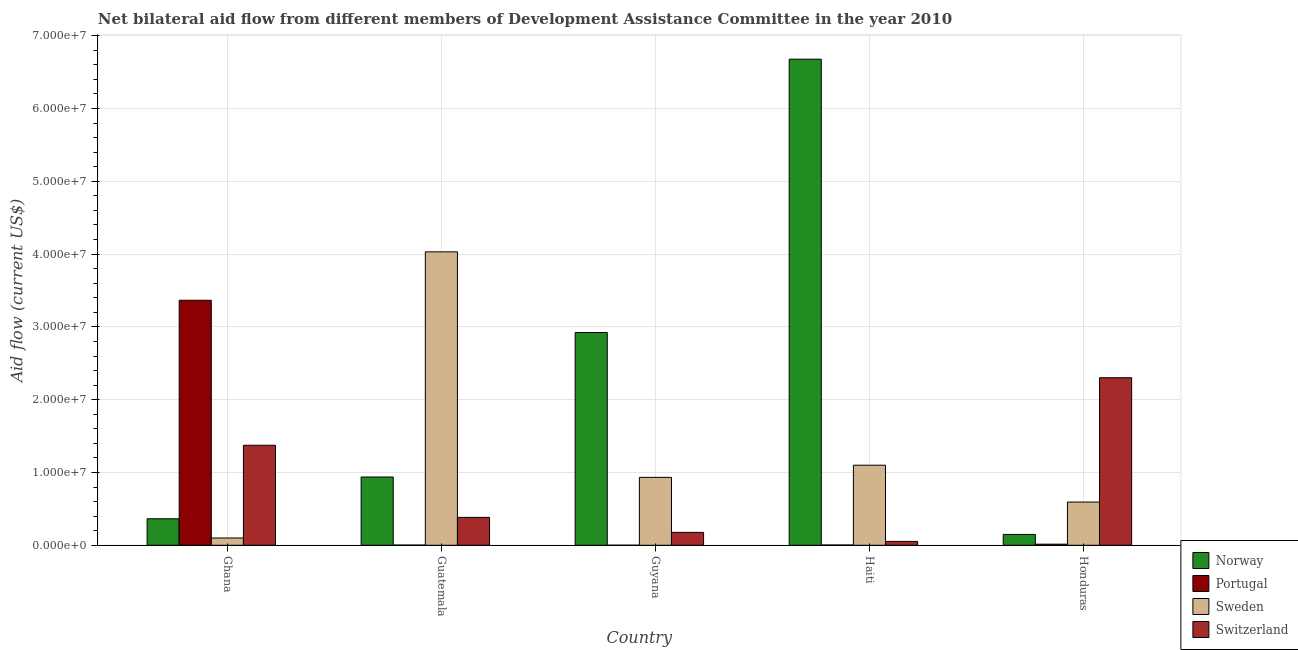What is the label of the 1st group of bars from the left?
Your response must be concise. Ghana. What is the amount of aid given by norway in Honduras?
Keep it short and to the point. 1.49e+06. Across all countries, what is the maximum amount of aid given by switzerland?
Your answer should be very brief. 2.30e+07. Across all countries, what is the minimum amount of aid given by norway?
Offer a terse response. 1.49e+06. In which country was the amount of aid given by sweden maximum?
Offer a very short reply. Guatemala. What is the total amount of aid given by sweden in the graph?
Your response must be concise. 6.76e+07. What is the difference between the amount of aid given by portugal in Ghana and that in Haiti?
Your answer should be very brief. 3.36e+07. What is the difference between the amount of aid given by portugal in Honduras and the amount of aid given by norway in Guatemala?
Your answer should be very brief. -9.23e+06. What is the average amount of aid given by sweden per country?
Provide a short and direct response. 1.35e+07. What is the difference between the amount of aid given by portugal and amount of aid given by sweden in Guatemala?
Offer a terse response. -4.03e+07. In how many countries, is the amount of aid given by sweden greater than 34000000 US$?
Your answer should be compact. 1. What is the ratio of the amount of aid given by switzerland in Guyana to that in Honduras?
Provide a short and direct response. 0.08. What is the difference between the highest and the second highest amount of aid given by norway?
Give a very brief answer. 3.76e+07. What is the difference between the highest and the lowest amount of aid given by sweden?
Your response must be concise. 3.93e+07. What does the 1st bar from the right in Haiti represents?
Your answer should be very brief. Switzerland. Is it the case that in every country, the sum of the amount of aid given by norway and amount of aid given by portugal is greater than the amount of aid given by sweden?
Your response must be concise. No. Are all the bars in the graph horizontal?
Offer a terse response. No. How many countries are there in the graph?
Ensure brevity in your answer.  5. Does the graph contain grids?
Offer a terse response. Yes. Where does the legend appear in the graph?
Provide a succinct answer. Bottom right. How many legend labels are there?
Provide a short and direct response. 4. How are the legend labels stacked?
Keep it short and to the point. Vertical. What is the title of the graph?
Provide a short and direct response. Net bilateral aid flow from different members of Development Assistance Committee in the year 2010. What is the label or title of the Y-axis?
Your answer should be very brief. Aid flow (current US$). What is the Aid flow (current US$) of Norway in Ghana?
Make the answer very short. 3.64e+06. What is the Aid flow (current US$) of Portugal in Ghana?
Give a very brief answer. 3.37e+07. What is the Aid flow (current US$) of Switzerland in Ghana?
Provide a succinct answer. 1.37e+07. What is the Aid flow (current US$) of Norway in Guatemala?
Your response must be concise. 9.38e+06. What is the Aid flow (current US$) in Sweden in Guatemala?
Keep it short and to the point. 4.03e+07. What is the Aid flow (current US$) of Switzerland in Guatemala?
Make the answer very short. 3.83e+06. What is the Aid flow (current US$) of Norway in Guyana?
Keep it short and to the point. 2.92e+07. What is the Aid flow (current US$) of Sweden in Guyana?
Offer a terse response. 9.33e+06. What is the Aid flow (current US$) of Switzerland in Guyana?
Offer a terse response. 1.77e+06. What is the Aid flow (current US$) of Norway in Haiti?
Your response must be concise. 6.68e+07. What is the Aid flow (current US$) in Sweden in Haiti?
Your answer should be compact. 1.10e+07. What is the Aid flow (current US$) in Switzerland in Haiti?
Keep it short and to the point. 5.30e+05. What is the Aid flow (current US$) of Norway in Honduras?
Your answer should be compact. 1.49e+06. What is the Aid flow (current US$) in Portugal in Honduras?
Your answer should be very brief. 1.50e+05. What is the Aid flow (current US$) in Sweden in Honduras?
Provide a short and direct response. 5.94e+06. What is the Aid flow (current US$) in Switzerland in Honduras?
Give a very brief answer. 2.30e+07. Across all countries, what is the maximum Aid flow (current US$) of Norway?
Your answer should be compact. 6.68e+07. Across all countries, what is the maximum Aid flow (current US$) of Portugal?
Provide a short and direct response. 3.37e+07. Across all countries, what is the maximum Aid flow (current US$) of Sweden?
Your response must be concise. 4.03e+07. Across all countries, what is the maximum Aid flow (current US$) of Switzerland?
Offer a very short reply. 2.30e+07. Across all countries, what is the minimum Aid flow (current US$) in Norway?
Give a very brief answer. 1.49e+06. Across all countries, what is the minimum Aid flow (current US$) in Portugal?
Provide a succinct answer. 10000. Across all countries, what is the minimum Aid flow (current US$) of Sweden?
Your answer should be compact. 1.00e+06. Across all countries, what is the minimum Aid flow (current US$) in Switzerland?
Offer a very short reply. 5.30e+05. What is the total Aid flow (current US$) of Norway in the graph?
Keep it short and to the point. 1.11e+08. What is the total Aid flow (current US$) of Portugal in the graph?
Your answer should be compact. 3.39e+07. What is the total Aid flow (current US$) in Sweden in the graph?
Keep it short and to the point. 6.76e+07. What is the total Aid flow (current US$) in Switzerland in the graph?
Offer a terse response. 4.29e+07. What is the difference between the Aid flow (current US$) in Norway in Ghana and that in Guatemala?
Give a very brief answer. -5.74e+06. What is the difference between the Aid flow (current US$) of Portugal in Ghana and that in Guatemala?
Give a very brief answer. 3.36e+07. What is the difference between the Aid flow (current US$) in Sweden in Ghana and that in Guatemala?
Provide a succinct answer. -3.93e+07. What is the difference between the Aid flow (current US$) in Switzerland in Ghana and that in Guatemala?
Offer a very short reply. 9.91e+06. What is the difference between the Aid flow (current US$) in Norway in Ghana and that in Guyana?
Provide a short and direct response. -2.56e+07. What is the difference between the Aid flow (current US$) of Portugal in Ghana and that in Guyana?
Offer a terse response. 3.36e+07. What is the difference between the Aid flow (current US$) of Sweden in Ghana and that in Guyana?
Give a very brief answer. -8.33e+06. What is the difference between the Aid flow (current US$) of Switzerland in Ghana and that in Guyana?
Provide a succinct answer. 1.20e+07. What is the difference between the Aid flow (current US$) in Norway in Ghana and that in Haiti?
Your answer should be compact. -6.31e+07. What is the difference between the Aid flow (current US$) of Portugal in Ghana and that in Haiti?
Keep it short and to the point. 3.36e+07. What is the difference between the Aid flow (current US$) of Sweden in Ghana and that in Haiti?
Make the answer very short. -1.00e+07. What is the difference between the Aid flow (current US$) of Switzerland in Ghana and that in Haiti?
Your answer should be compact. 1.32e+07. What is the difference between the Aid flow (current US$) of Norway in Ghana and that in Honduras?
Your answer should be compact. 2.15e+06. What is the difference between the Aid flow (current US$) of Portugal in Ghana and that in Honduras?
Give a very brief answer. 3.35e+07. What is the difference between the Aid flow (current US$) of Sweden in Ghana and that in Honduras?
Make the answer very short. -4.94e+06. What is the difference between the Aid flow (current US$) of Switzerland in Ghana and that in Honduras?
Offer a very short reply. -9.28e+06. What is the difference between the Aid flow (current US$) in Norway in Guatemala and that in Guyana?
Your response must be concise. -1.98e+07. What is the difference between the Aid flow (current US$) in Sweden in Guatemala and that in Guyana?
Your response must be concise. 3.10e+07. What is the difference between the Aid flow (current US$) in Switzerland in Guatemala and that in Guyana?
Make the answer very short. 2.06e+06. What is the difference between the Aid flow (current US$) of Norway in Guatemala and that in Haiti?
Provide a short and direct response. -5.74e+07. What is the difference between the Aid flow (current US$) in Sweden in Guatemala and that in Haiti?
Keep it short and to the point. 2.93e+07. What is the difference between the Aid flow (current US$) in Switzerland in Guatemala and that in Haiti?
Make the answer very short. 3.30e+06. What is the difference between the Aid flow (current US$) in Norway in Guatemala and that in Honduras?
Provide a succinct answer. 7.89e+06. What is the difference between the Aid flow (current US$) of Portugal in Guatemala and that in Honduras?
Your response must be concise. -1.20e+05. What is the difference between the Aid flow (current US$) in Sweden in Guatemala and that in Honduras?
Offer a very short reply. 3.44e+07. What is the difference between the Aid flow (current US$) of Switzerland in Guatemala and that in Honduras?
Your answer should be compact. -1.92e+07. What is the difference between the Aid flow (current US$) in Norway in Guyana and that in Haiti?
Make the answer very short. -3.76e+07. What is the difference between the Aid flow (current US$) in Portugal in Guyana and that in Haiti?
Offer a very short reply. -3.00e+04. What is the difference between the Aid flow (current US$) in Sweden in Guyana and that in Haiti?
Offer a terse response. -1.67e+06. What is the difference between the Aid flow (current US$) in Switzerland in Guyana and that in Haiti?
Your answer should be very brief. 1.24e+06. What is the difference between the Aid flow (current US$) of Norway in Guyana and that in Honduras?
Ensure brevity in your answer.  2.77e+07. What is the difference between the Aid flow (current US$) of Sweden in Guyana and that in Honduras?
Provide a short and direct response. 3.39e+06. What is the difference between the Aid flow (current US$) in Switzerland in Guyana and that in Honduras?
Your response must be concise. -2.12e+07. What is the difference between the Aid flow (current US$) of Norway in Haiti and that in Honduras?
Give a very brief answer. 6.53e+07. What is the difference between the Aid flow (current US$) of Sweden in Haiti and that in Honduras?
Make the answer very short. 5.06e+06. What is the difference between the Aid flow (current US$) in Switzerland in Haiti and that in Honduras?
Give a very brief answer. -2.25e+07. What is the difference between the Aid flow (current US$) of Norway in Ghana and the Aid flow (current US$) of Portugal in Guatemala?
Your answer should be compact. 3.61e+06. What is the difference between the Aid flow (current US$) in Norway in Ghana and the Aid flow (current US$) in Sweden in Guatemala?
Ensure brevity in your answer.  -3.67e+07. What is the difference between the Aid flow (current US$) of Norway in Ghana and the Aid flow (current US$) of Switzerland in Guatemala?
Provide a short and direct response. -1.90e+05. What is the difference between the Aid flow (current US$) of Portugal in Ghana and the Aid flow (current US$) of Sweden in Guatemala?
Ensure brevity in your answer.  -6.65e+06. What is the difference between the Aid flow (current US$) of Portugal in Ghana and the Aid flow (current US$) of Switzerland in Guatemala?
Give a very brief answer. 2.98e+07. What is the difference between the Aid flow (current US$) in Sweden in Ghana and the Aid flow (current US$) in Switzerland in Guatemala?
Offer a very short reply. -2.83e+06. What is the difference between the Aid flow (current US$) in Norway in Ghana and the Aid flow (current US$) in Portugal in Guyana?
Your response must be concise. 3.63e+06. What is the difference between the Aid flow (current US$) in Norway in Ghana and the Aid flow (current US$) in Sweden in Guyana?
Make the answer very short. -5.69e+06. What is the difference between the Aid flow (current US$) of Norway in Ghana and the Aid flow (current US$) of Switzerland in Guyana?
Offer a very short reply. 1.87e+06. What is the difference between the Aid flow (current US$) in Portugal in Ghana and the Aid flow (current US$) in Sweden in Guyana?
Make the answer very short. 2.43e+07. What is the difference between the Aid flow (current US$) in Portugal in Ghana and the Aid flow (current US$) in Switzerland in Guyana?
Your answer should be very brief. 3.19e+07. What is the difference between the Aid flow (current US$) of Sweden in Ghana and the Aid flow (current US$) of Switzerland in Guyana?
Make the answer very short. -7.70e+05. What is the difference between the Aid flow (current US$) in Norway in Ghana and the Aid flow (current US$) in Portugal in Haiti?
Provide a succinct answer. 3.60e+06. What is the difference between the Aid flow (current US$) of Norway in Ghana and the Aid flow (current US$) of Sweden in Haiti?
Give a very brief answer. -7.36e+06. What is the difference between the Aid flow (current US$) of Norway in Ghana and the Aid flow (current US$) of Switzerland in Haiti?
Your answer should be very brief. 3.11e+06. What is the difference between the Aid flow (current US$) of Portugal in Ghana and the Aid flow (current US$) of Sweden in Haiti?
Provide a short and direct response. 2.27e+07. What is the difference between the Aid flow (current US$) in Portugal in Ghana and the Aid flow (current US$) in Switzerland in Haiti?
Your answer should be very brief. 3.31e+07. What is the difference between the Aid flow (current US$) in Norway in Ghana and the Aid flow (current US$) in Portugal in Honduras?
Make the answer very short. 3.49e+06. What is the difference between the Aid flow (current US$) in Norway in Ghana and the Aid flow (current US$) in Sweden in Honduras?
Make the answer very short. -2.30e+06. What is the difference between the Aid flow (current US$) in Norway in Ghana and the Aid flow (current US$) in Switzerland in Honduras?
Your answer should be very brief. -1.94e+07. What is the difference between the Aid flow (current US$) of Portugal in Ghana and the Aid flow (current US$) of Sweden in Honduras?
Offer a terse response. 2.77e+07. What is the difference between the Aid flow (current US$) of Portugal in Ghana and the Aid flow (current US$) of Switzerland in Honduras?
Give a very brief answer. 1.06e+07. What is the difference between the Aid flow (current US$) of Sweden in Ghana and the Aid flow (current US$) of Switzerland in Honduras?
Provide a succinct answer. -2.20e+07. What is the difference between the Aid flow (current US$) in Norway in Guatemala and the Aid flow (current US$) in Portugal in Guyana?
Offer a terse response. 9.37e+06. What is the difference between the Aid flow (current US$) in Norway in Guatemala and the Aid flow (current US$) in Sweden in Guyana?
Give a very brief answer. 5.00e+04. What is the difference between the Aid flow (current US$) in Norway in Guatemala and the Aid flow (current US$) in Switzerland in Guyana?
Provide a succinct answer. 7.61e+06. What is the difference between the Aid flow (current US$) in Portugal in Guatemala and the Aid flow (current US$) in Sweden in Guyana?
Ensure brevity in your answer.  -9.30e+06. What is the difference between the Aid flow (current US$) of Portugal in Guatemala and the Aid flow (current US$) of Switzerland in Guyana?
Your answer should be very brief. -1.74e+06. What is the difference between the Aid flow (current US$) in Sweden in Guatemala and the Aid flow (current US$) in Switzerland in Guyana?
Offer a very short reply. 3.85e+07. What is the difference between the Aid flow (current US$) in Norway in Guatemala and the Aid flow (current US$) in Portugal in Haiti?
Your answer should be compact. 9.34e+06. What is the difference between the Aid flow (current US$) in Norway in Guatemala and the Aid flow (current US$) in Sweden in Haiti?
Offer a terse response. -1.62e+06. What is the difference between the Aid flow (current US$) of Norway in Guatemala and the Aid flow (current US$) of Switzerland in Haiti?
Offer a very short reply. 8.85e+06. What is the difference between the Aid flow (current US$) of Portugal in Guatemala and the Aid flow (current US$) of Sweden in Haiti?
Your answer should be very brief. -1.10e+07. What is the difference between the Aid flow (current US$) of Portugal in Guatemala and the Aid flow (current US$) of Switzerland in Haiti?
Keep it short and to the point. -5.00e+05. What is the difference between the Aid flow (current US$) in Sweden in Guatemala and the Aid flow (current US$) in Switzerland in Haiti?
Your answer should be compact. 3.98e+07. What is the difference between the Aid flow (current US$) of Norway in Guatemala and the Aid flow (current US$) of Portugal in Honduras?
Provide a short and direct response. 9.23e+06. What is the difference between the Aid flow (current US$) in Norway in Guatemala and the Aid flow (current US$) in Sweden in Honduras?
Your response must be concise. 3.44e+06. What is the difference between the Aid flow (current US$) of Norway in Guatemala and the Aid flow (current US$) of Switzerland in Honduras?
Give a very brief answer. -1.36e+07. What is the difference between the Aid flow (current US$) of Portugal in Guatemala and the Aid flow (current US$) of Sweden in Honduras?
Provide a short and direct response. -5.91e+06. What is the difference between the Aid flow (current US$) in Portugal in Guatemala and the Aid flow (current US$) in Switzerland in Honduras?
Offer a very short reply. -2.30e+07. What is the difference between the Aid flow (current US$) of Sweden in Guatemala and the Aid flow (current US$) of Switzerland in Honduras?
Give a very brief answer. 1.73e+07. What is the difference between the Aid flow (current US$) of Norway in Guyana and the Aid flow (current US$) of Portugal in Haiti?
Your response must be concise. 2.92e+07. What is the difference between the Aid flow (current US$) in Norway in Guyana and the Aid flow (current US$) in Sweden in Haiti?
Your answer should be compact. 1.82e+07. What is the difference between the Aid flow (current US$) in Norway in Guyana and the Aid flow (current US$) in Switzerland in Haiti?
Offer a very short reply. 2.87e+07. What is the difference between the Aid flow (current US$) in Portugal in Guyana and the Aid flow (current US$) in Sweden in Haiti?
Ensure brevity in your answer.  -1.10e+07. What is the difference between the Aid flow (current US$) in Portugal in Guyana and the Aid flow (current US$) in Switzerland in Haiti?
Ensure brevity in your answer.  -5.20e+05. What is the difference between the Aid flow (current US$) of Sweden in Guyana and the Aid flow (current US$) of Switzerland in Haiti?
Offer a very short reply. 8.80e+06. What is the difference between the Aid flow (current US$) of Norway in Guyana and the Aid flow (current US$) of Portugal in Honduras?
Offer a terse response. 2.91e+07. What is the difference between the Aid flow (current US$) of Norway in Guyana and the Aid flow (current US$) of Sweden in Honduras?
Make the answer very short. 2.33e+07. What is the difference between the Aid flow (current US$) in Norway in Guyana and the Aid flow (current US$) in Switzerland in Honduras?
Keep it short and to the point. 6.21e+06. What is the difference between the Aid flow (current US$) of Portugal in Guyana and the Aid flow (current US$) of Sweden in Honduras?
Provide a short and direct response. -5.93e+06. What is the difference between the Aid flow (current US$) of Portugal in Guyana and the Aid flow (current US$) of Switzerland in Honduras?
Give a very brief answer. -2.30e+07. What is the difference between the Aid flow (current US$) of Sweden in Guyana and the Aid flow (current US$) of Switzerland in Honduras?
Your answer should be compact. -1.37e+07. What is the difference between the Aid flow (current US$) of Norway in Haiti and the Aid flow (current US$) of Portugal in Honduras?
Give a very brief answer. 6.66e+07. What is the difference between the Aid flow (current US$) of Norway in Haiti and the Aid flow (current US$) of Sweden in Honduras?
Provide a succinct answer. 6.08e+07. What is the difference between the Aid flow (current US$) in Norway in Haiti and the Aid flow (current US$) in Switzerland in Honduras?
Keep it short and to the point. 4.38e+07. What is the difference between the Aid flow (current US$) in Portugal in Haiti and the Aid flow (current US$) in Sweden in Honduras?
Provide a short and direct response. -5.90e+06. What is the difference between the Aid flow (current US$) of Portugal in Haiti and the Aid flow (current US$) of Switzerland in Honduras?
Give a very brief answer. -2.30e+07. What is the difference between the Aid flow (current US$) of Sweden in Haiti and the Aid flow (current US$) of Switzerland in Honduras?
Your answer should be very brief. -1.20e+07. What is the average Aid flow (current US$) of Norway per country?
Offer a terse response. 2.21e+07. What is the average Aid flow (current US$) of Portugal per country?
Offer a terse response. 6.78e+06. What is the average Aid flow (current US$) in Sweden per country?
Provide a short and direct response. 1.35e+07. What is the average Aid flow (current US$) of Switzerland per country?
Make the answer very short. 8.58e+06. What is the difference between the Aid flow (current US$) of Norway and Aid flow (current US$) of Portugal in Ghana?
Provide a succinct answer. -3.00e+07. What is the difference between the Aid flow (current US$) of Norway and Aid flow (current US$) of Sweden in Ghana?
Ensure brevity in your answer.  2.64e+06. What is the difference between the Aid flow (current US$) in Norway and Aid flow (current US$) in Switzerland in Ghana?
Give a very brief answer. -1.01e+07. What is the difference between the Aid flow (current US$) in Portugal and Aid flow (current US$) in Sweden in Ghana?
Your answer should be very brief. 3.27e+07. What is the difference between the Aid flow (current US$) of Portugal and Aid flow (current US$) of Switzerland in Ghana?
Offer a terse response. 1.99e+07. What is the difference between the Aid flow (current US$) of Sweden and Aid flow (current US$) of Switzerland in Ghana?
Keep it short and to the point. -1.27e+07. What is the difference between the Aid flow (current US$) of Norway and Aid flow (current US$) of Portugal in Guatemala?
Provide a short and direct response. 9.35e+06. What is the difference between the Aid flow (current US$) of Norway and Aid flow (current US$) of Sweden in Guatemala?
Make the answer very short. -3.09e+07. What is the difference between the Aid flow (current US$) of Norway and Aid flow (current US$) of Switzerland in Guatemala?
Your response must be concise. 5.55e+06. What is the difference between the Aid flow (current US$) of Portugal and Aid flow (current US$) of Sweden in Guatemala?
Your response must be concise. -4.03e+07. What is the difference between the Aid flow (current US$) of Portugal and Aid flow (current US$) of Switzerland in Guatemala?
Ensure brevity in your answer.  -3.80e+06. What is the difference between the Aid flow (current US$) in Sweden and Aid flow (current US$) in Switzerland in Guatemala?
Keep it short and to the point. 3.65e+07. What is the difference between the Aid flow (current US$) in Norway and Aid flow (current US$) in Portugal in Guyana?
Your answer should be very brief. 2.92e+07. What is the difference between the Aid flow (current US$) of Norway and Aid flow (current US$) of Sweden in Guyana?
Ensure brevity in your answer.  1.99e+07. What is the difference between the Aid flow (current US$) in Norway and Aid flow (current US$) in Switzerland in Guyana?
Keep it short and to the point. 2.75e+07. What is the difference between the Aid flow (current US$) of Portugal and Aid flow (current US$) of Sweden in Guyana?
Keep it short and to the point. -9.32e+06. What is the difference between the Aid flow (current US$) of Portugal and Aid flow (current US$) of Switzerland in Guyana?
Your response must be concise. -1.76e+06. What is the difference between the Aid flow (current US$) in Sweden and Aid flow (current US$) in Switzerland in Guyana?
Give a very brief answer. 7.56e+06. What is the difference between the Aid flow (current US$) of Norway and Aid flow (current US$) of Portugal in Haiti?
Ensure brevity in your answer.  6.67e+07. What is the difference between the Aid flow (current US$) in Norway and Aid flow (current US$) in Sweden in Haiti?
Your answer should be compact. 5.58e+07. What is the difference between the Aid flow (current US$) of Norway and Aid flow (current US$) of Switzerland in Haiti?
Your response must be concise. 6.62e+07. What is the difference between the Aid flow (current US$) of Portugal and Aid flow (current US$) of Sweden in Haiti?
Your answer should be very brief. -1.10e+07. What is the difference between the Aid flow (current US$) in Portugal and Aid flow (current US$) in Switzerland in Haiti?
Keep it short and to the point. -4.90e+05. What is the difference between the Aid flow (current US$) in Sweden and Aid flow (current US$) in Switzerland in Haiti?
Your response must be concise. 1.05e+07. What is the difference between the Aid flow (current US$) in Norway and Aid flow (current US$) in Portugal in Honduras?
Give a very brief answer. 1.34e+06. What is the difference between the Aid flow (current US$) of Norway and Aid flow (current US$) of Sweden in Honduras?
Your response must be concise. -4.45e+06. What is the difference between the Aid flow (current US$) of Norway and Aid flow (current US$) of Switzerland in Honduras?
Your answer should be very brief. -2.15e+07. What is the difference between the Aid flow (current US$) in Portugal and Aid flow (current US$) in Sweden in Honduras?
Your answer should be very brief. -5.79e+06. What is the difference between the Aid flow (current US$) of Portugal and Aid flow (current US$) of Switzerland in Honduras?
Provide a short and direct response. -2.29e+07. What is the difference between the Aid flow (current US$) in Sweden and Aid flow (current US$) in Switzerland in Honduras?
Your answer should be very brief. -1.71e+07. What is the ratio of the Aid flow (current US$) of Norway in Ghana to that in Guatemala?
Your answer should be compact. 0.39. What is the ratio of the Aid flow (current US$) in Portugal in Ghana to that in Guatemala?
Offer a very short reply. 1122. What is the ratio of the Aid flow (current US$) of Sweden in Ghana to that in Guatemala?
Your answer should be compact. 0.02. What is the ratio of the Aid flow (current US$) of Switzerland in Ghana to that in Guatemala?
Provide a succinct answer. 3.59. What is the ratio of the Aid flow (current US$) of Norway in Ghana to that in Guyana?
Offer a terse response. 0.12. What is the ratio of the Aid flow (current US$) of Portugal in Ghana to that in Guyana?
Make the answer very short. 3366. What is the ratio of the Aid flow (current US$) in Sweden in Ghana to that in Guyana?
Your response must be concise. 0.11. What is the ratio of the Aid flow (current US$) in Switzerland in Ghana to that in Guyana?
Give a very brief answer. 7.76. What is the ratio of the Aid flow (current US$) in Norway in Ghana to that in Haiti?
Give a very brief answer. 0.05. What is the ratio of the Aid flow (current US$) of Portugal in Ghana to that in Haiti?
Offer a terse response. 841.5. What is the ratio of the Aid flow (current US$) in Sweden in Ghana to that in Haiti?
Keep it short and to the point. 0.09. What is the ratio of the Aid flow (current US$) of Switzerland in Ghana to that in Haiti?
Offer a very short reply. 25.92. What is the ratio of the Aid flow (current US$) of Norway in Ghana to that in Honduras?
Your answer should be compact. 2.44. What is the ratio of the Aid flow (current US$) in Portugal in Ghana to that in Honduras?
Your response must be concise. 224.4. What is the ratio of the Aid flow (current US$) of Sweden in Ghana to that in Honduras?
Keep it short and to the point. 0.17. What is the ratio of the Aid flow (current US$) in Switzerland in Ghana to that in Honduras?
Offer a very short reply. 0.6. What is the ratio of the Aid flow (current US$) of Norway in Guatemala to that in Guyana?
Ensure brevity in your answer.  0.32. What is the ratio of the Aid flow (current US$) of Portugal in Guatemala to that in Guyana?
Give a very brief answer. 3. What is the ratio of the Aid flow (current US$) of Sweden in Guatemala to that in Guyana?
Make the answer very short. 4.32. What is the ratio of the Aid flow (current US$) in Switzerland in Guatemala to that in Guyana?
Your answer should be very brief. 2.16. What is the ratio of the Aid flow (current US$) in Norway in Guatemala to that in Haiti?
Give a very brief answer. 0.14. What is the ratio of the Aid flow (current US$) of Sweden in Guatemala to that in Haiti?
Ensure brevity in your answer.  3.66. What is the ratio of the Aid flow (current US$) in Switzerland in Guatemala to that in Haiti?
Offer a very short reply. 7.23. What is the ratio of the Aid flow (current US$) in Norway in Guatemala to that in Honduras?
Keep it short and to the point. 6.3. What is the ratio of the Aid flow (current US$) of Sweden in Guatemala to that in Honduras?
Give a very brief answer. 6.79. What is the ratio of the Aid flow (current US$) in Switzerland in Guatemala to that in Honduras?
Provide a short and direct response. 0.17. What is the ratio of the Aid flow (current US$) of Norway in Guyana to that in Haiti?
Provide a succinct answer. 0.44. What is the ratio of the Aid flow (current US$) of Portugal in Guyana to that in Haiti?
Provide a short and direct response. 0.25. What is the ratio of the Aid flow (current US$) in Sweden in Guyana to that in Haiti?
Make the answer very short. 0.85. What is the ratio of the Aid flow (current US$) of Switzerland in Guyana to that in Haiti?
Offer a very short reply. 3.34. What is the ratio of the Aid flow (current US$) of Norway in Guyana to that in Honduras?
Your answer should be very brief. 19.62. What is the ratio of the Aid flow (current US$) of Portugal in Guyana to that in Honduras?
Your answer should be very brief. 0.07. What is the ratio of the Aid flow (current US$) in Sweden in Guyana to that in Honduras?
Give a very brief answer. 1.57. What is the ratio of the Aid flow (current US$) of Switzerland in Guyana to that in Honduras?
Make the answer very short. 0.08. What is the ratio of the Aid flow (current US$) in Norway in Haiti to that in Honduras?
Ensure brevity in your answer.  44.82. What is the ratio of the Aid flow (current US$) of Portugal in Haiti to that in Honduras?
Provide a succinct answer. 0.27. What is the ratio of the Aid flow (current US$) in Sweden in Haiti to that in Honduras?
Keep it short and to the point. 1.85. What is the ratio of the Aid flow (current US$) of Switzerland in Haiti to that in Honduras?
Keep it short and to the point. 0.02. What is the difference between the highest and the second highest Aid flow (current US$) of Norway?
Ensure brevity in your answer.  3.76e+07. What is the difference between the highest and the second highest Aid flow (current US$) of Portugal?
Offer a terse response. 3.35e+07. What is the difference between the highest and the second highest Aid flow (current US$) in Sweden?
Ensure brevity in your answer.  2.93e+07. What is the difference between the highest and the second highest Aid flow (current US$) of Switzerland?
Make the answer very short. 9.28e+06. What is the difference between the highest and the lowest Aid flow (current US$) in Norway?
Offer a very short reply. 6.53e+07. What is the difference between the highest and the lowest Aid flow (current US$) in Portugal?
Your answer should be very brief. 3.36e+07. What is the difference between the highest and the lowest Aid flow (current US$) in Sweden?
Ensure brevity in your answer.  3.93e+07. What is the difference between the highest and the lowest Aid flow (current US$) in Switzerland?
Offer a very short reply. 2.25e+07. 